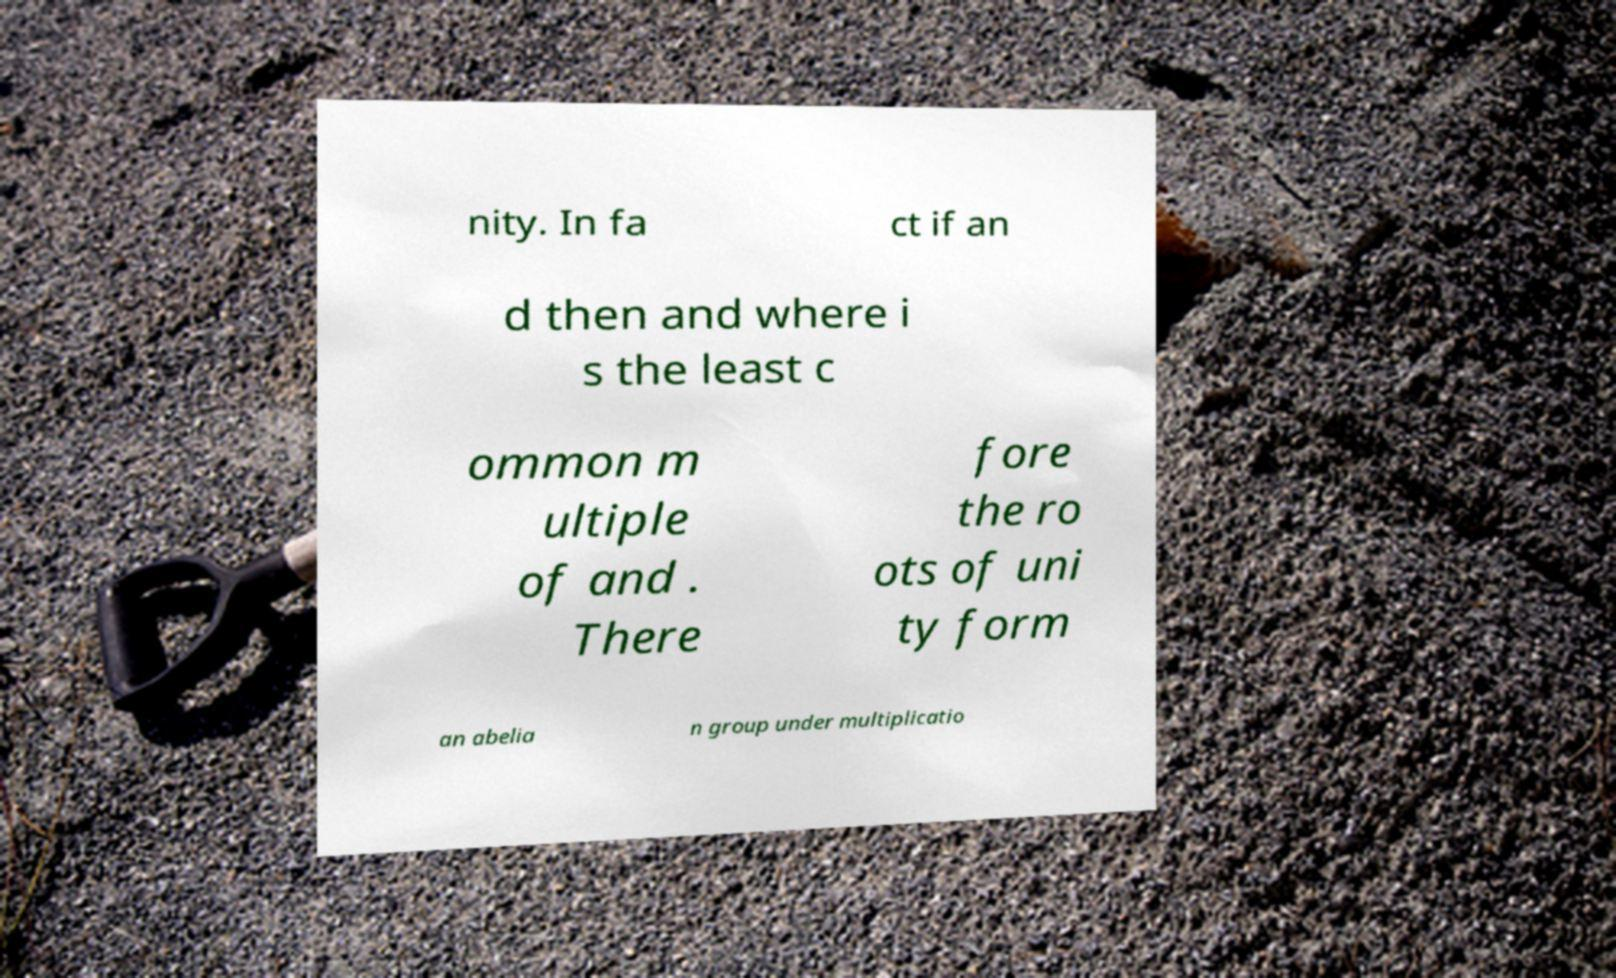Please read and relay the text visible in this image. What does it say? nity. In fa ct if an d then and where i s the least c ommon m ultiple of and . There fore the ro ots of uni ty form an abelia n group under multiplicatio 